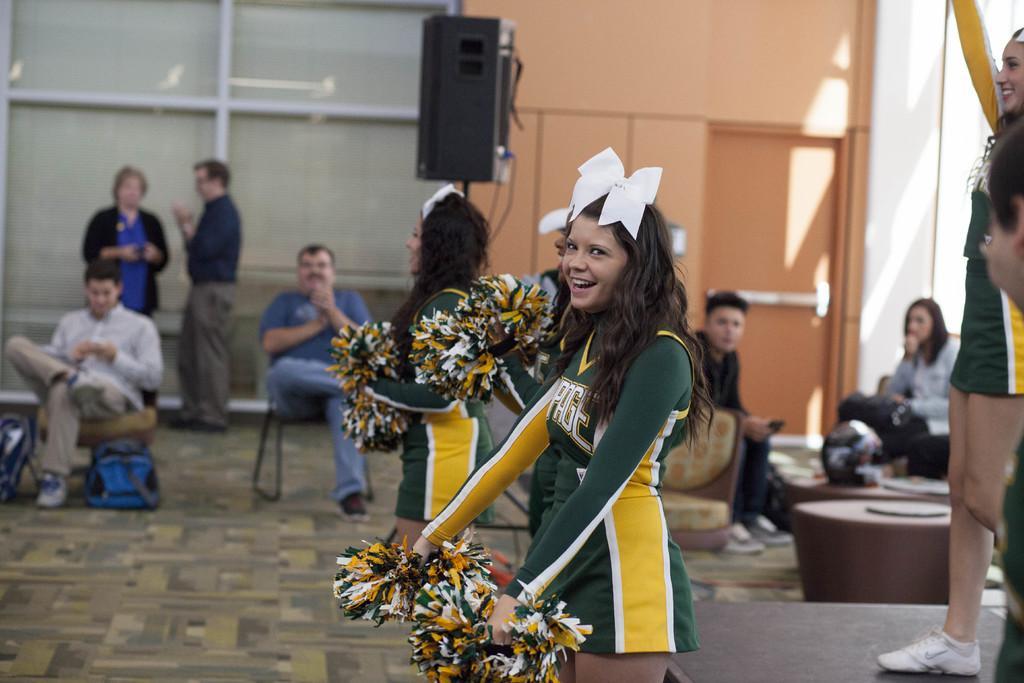Could you give a brief overview of what you see in this image? In this picture I can see the cheer girls. I can see a few people sitting. I can see the speaker. I can see a few people standing. 